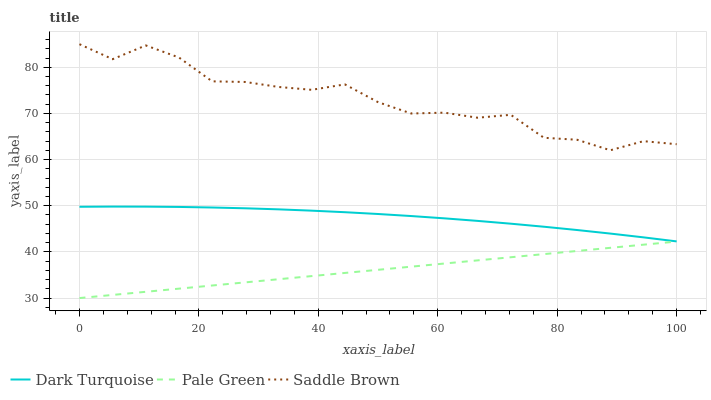Does Pale Green have the minimum area under the curve?
Answer yes or no. Yes. Does Saddle Brown have the maximum area under the curve?
Answer yes or no. Yes. Does Saddle Brown have the minimum area under the curve?
Answer yes or no. No. Does Pale Green have the maximum area under the curve?
Answer yes or no. No. Is Pale Green the smoothest?
Answer yes or no. Yes. Is Saddle Brown the roughest?
Answer yes or no. Yes. Is Saddle Brown the smoothest?
Answer yes or no. No. Is Pale Green the roughest?
Answer yes or no. No. Does Pale Green have the lowest value?
Answer yes or no. Yes. Does Saddle Brown have the lowest value?
Answer yes or no. No. Does Saddle Brown have the highest value?
Answer yes or no. Yes. Does Pale Green have the highest value?
Answer yes or no. No. Is Pale Green less than Dark Turquoise?
Answer yes or no. Yes. Is Saddle Brown greater than Dark Turquoise?
Answer yes or no. Yes. Does Pale Green intersect Dark Turquoise?
Answer yes or no. No. 